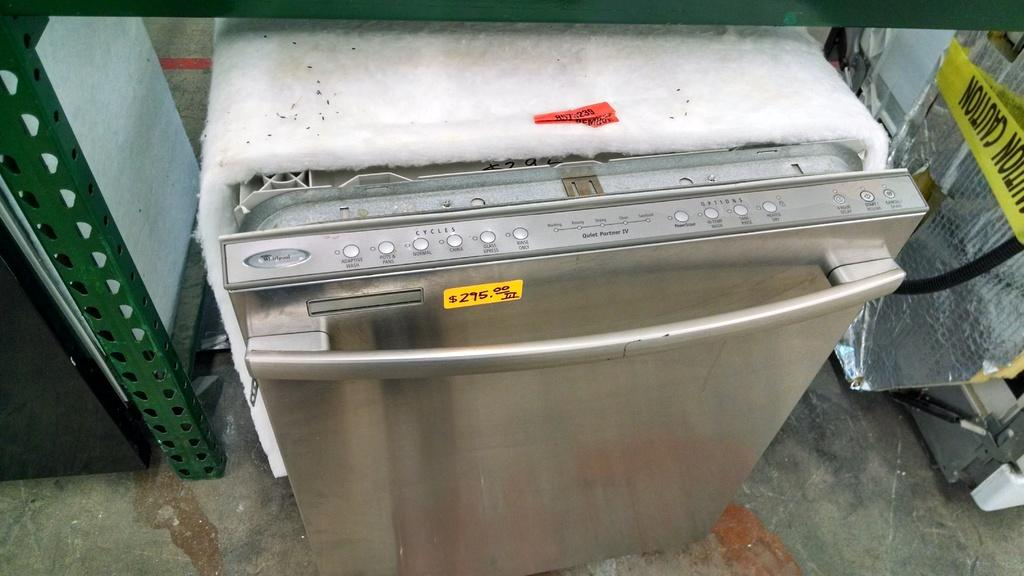<image>
Give a short and clear explanation of the subsequent image. an appliance that has $295.00 written on it 